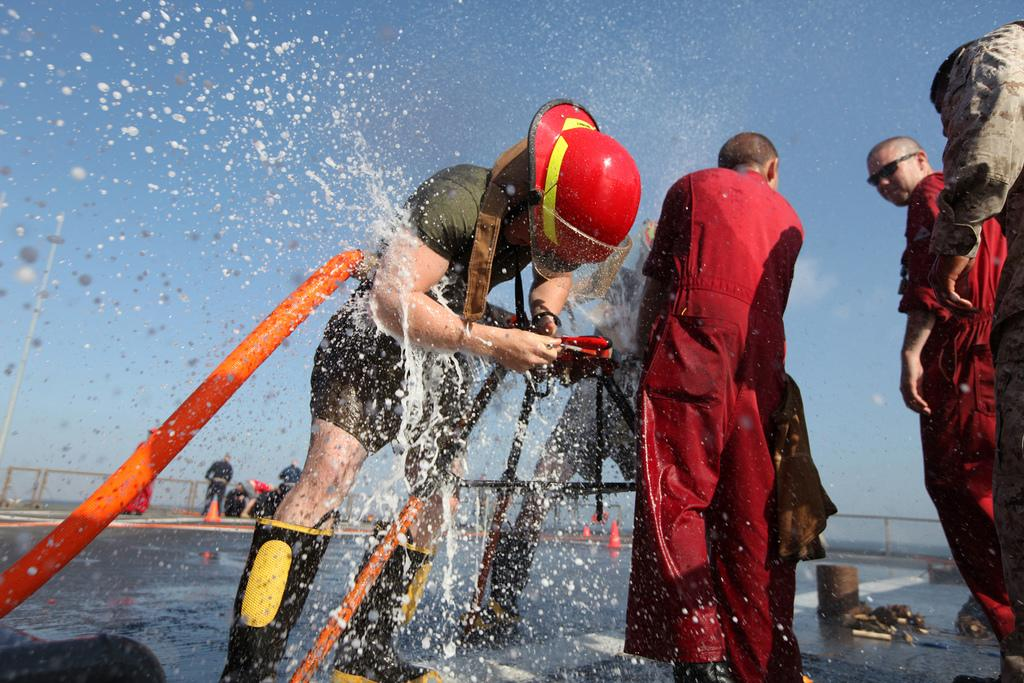What is the person in the image holding? The person is holding an object, which appears to be a pipe. What can be seen in the background of the image? There is water visible in the image, as well as a road and cone barricades. What type of material is visible in the image? Iron rods are visible in the image. How many people are present in the image? There is a group of people standing in the image, in addition to the person holding the pipe. What is visible in the sky in the image? The sky is visible in the image, but no specific details about the sky are mentioned in the facts. What type of square is being used as a trampoline in the image? There is no square or trampoline present in the image. 